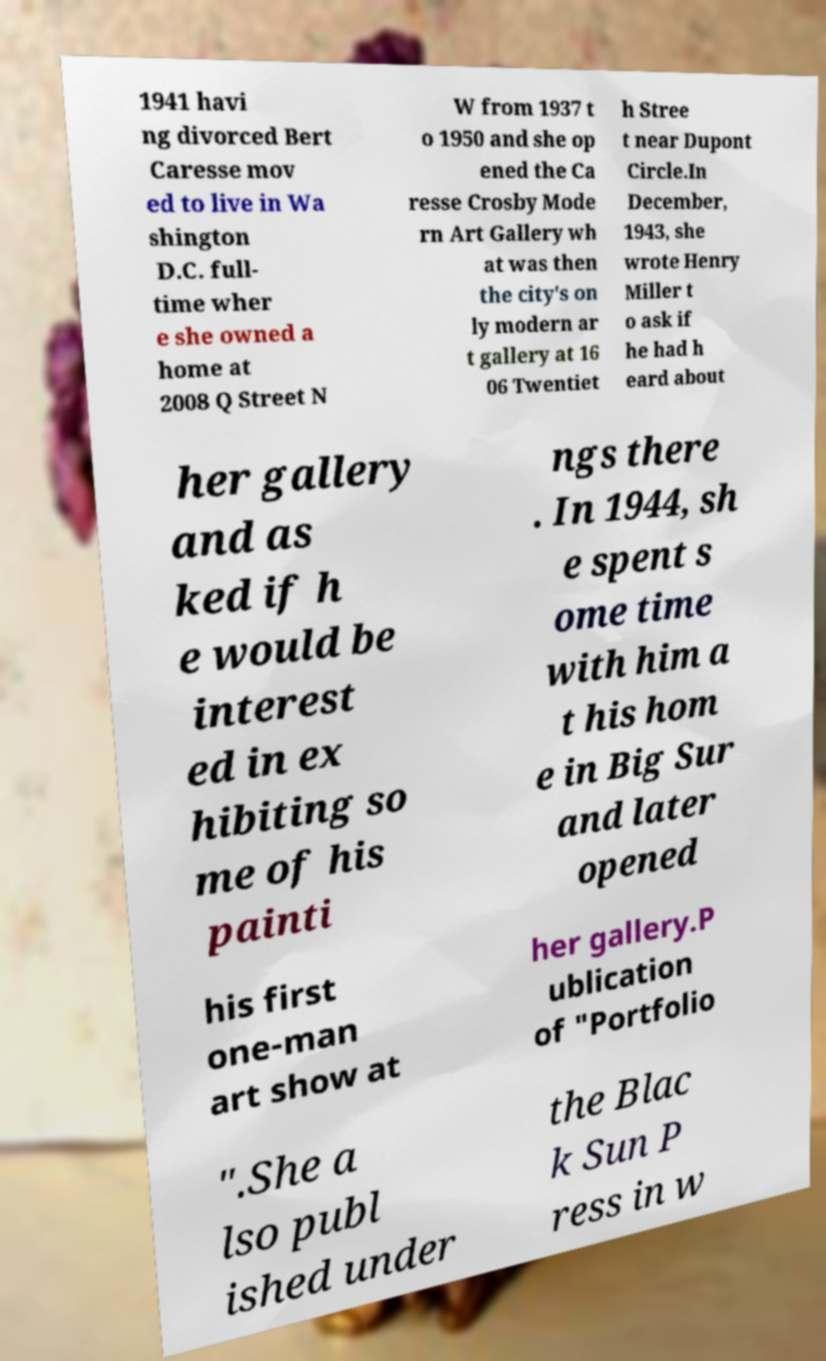Could you extract and type out the text from this image? 1941 havi ng divorced Bert Caresse mov ed to live in Wa shington D.C. full- time wher e she owned a home at 2008 Q Street N W from 1937 t o 1950 and she op ened the Ca resse Crosby Mode rn Art Gallery wh at was then the city's on ly modern ar t gallery at 16 06 Twentiet h Stree t near Dupont Circle.In December, 1943, she wrote Henry Miller t o ask if he had h eard about her gallery and as ked if h e would be interest ed in ex hibiting so me of his painti ngs there . In 1944, sh e spent s ome time with him a t his hom e in Big Sur and later opened his first one-man art show at her gallery.P ublication of "Portfolio ".She a lso publ ished under the Blac k Sun P ress in w 